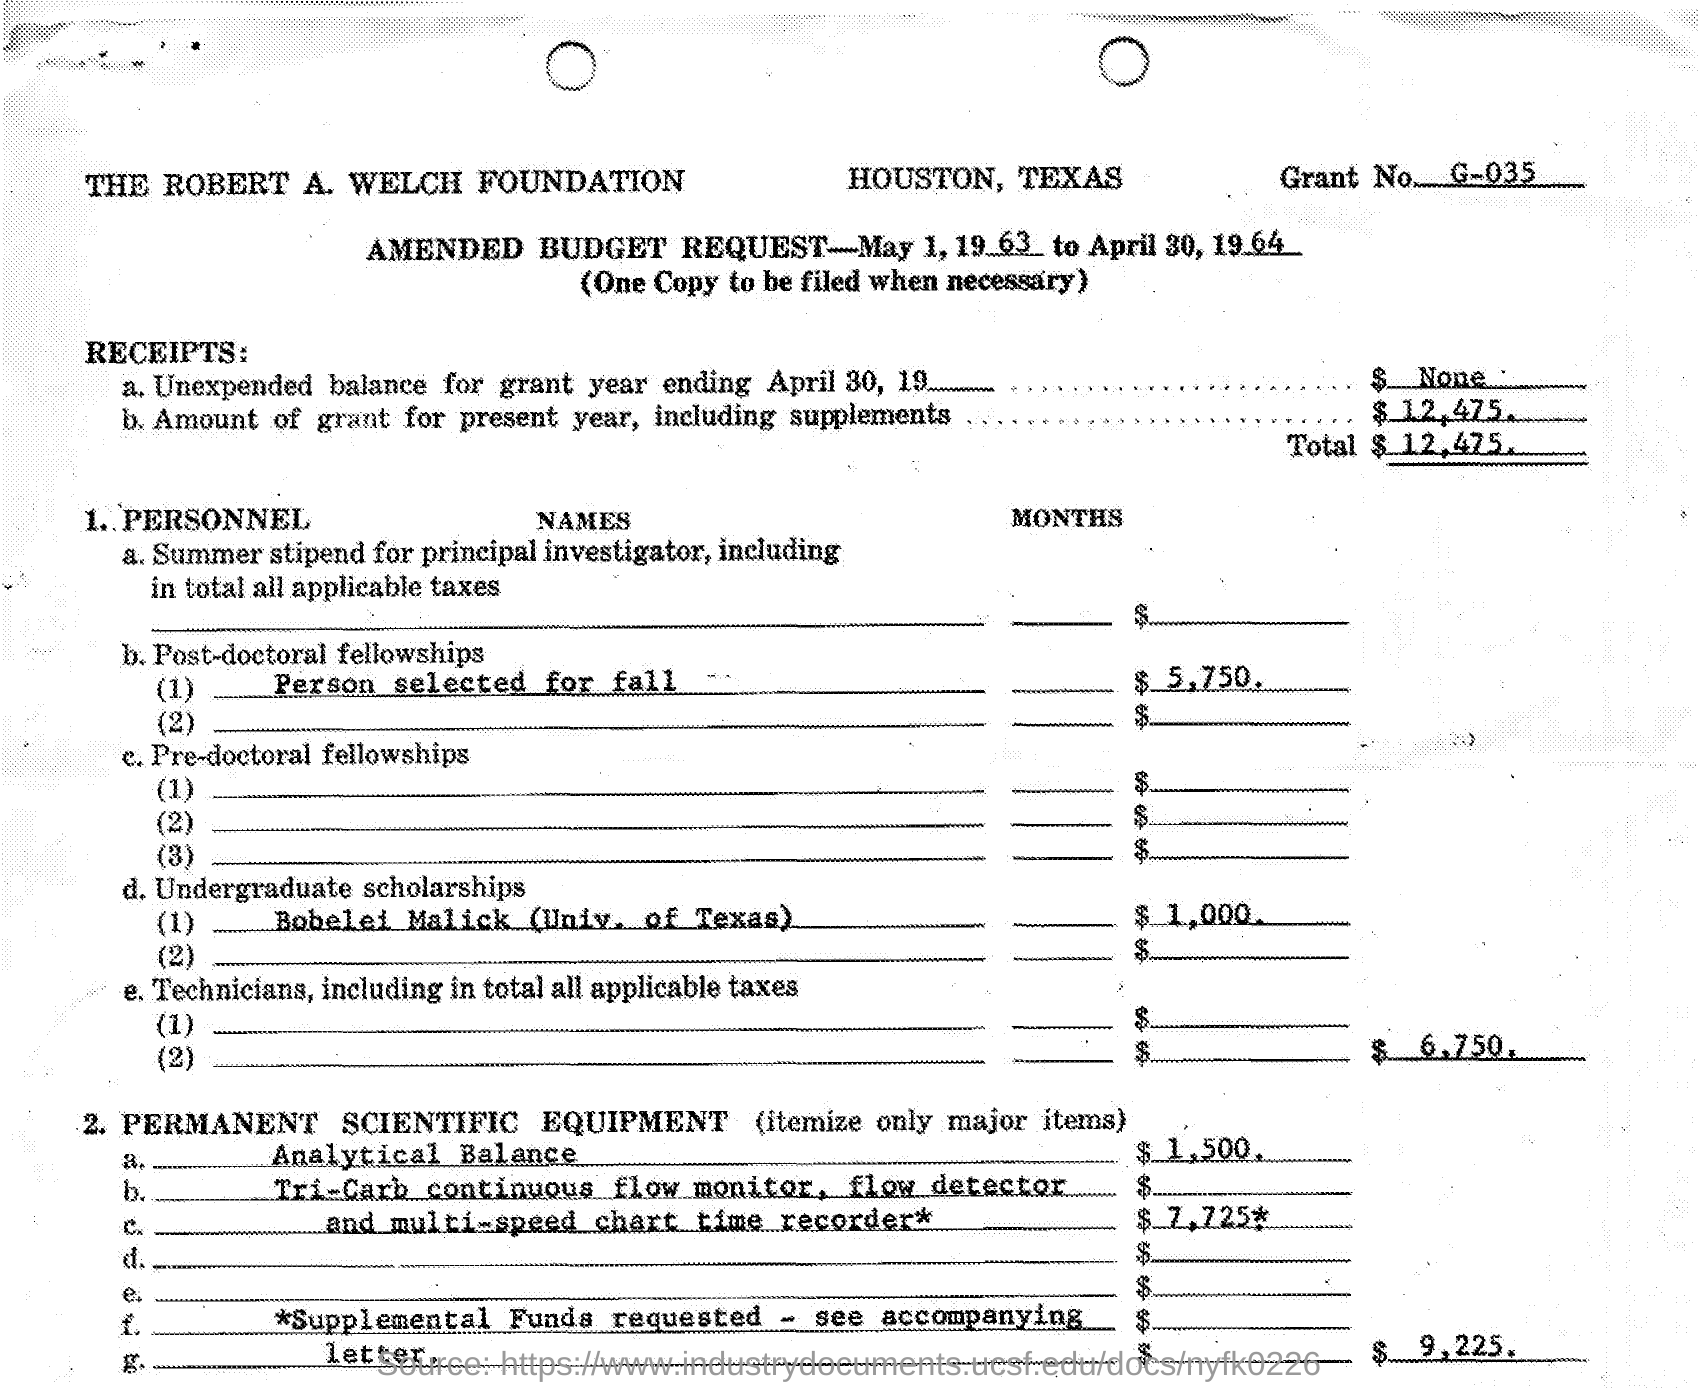Which foundation is mentioned?
Your response must be concise. THE ROBERT A. WELCH FOUNDATION. What is the grant No.?
Offer a terse response. G-035. What is the amount of Bobelei Malick (Univ. of Texas) for undergraduate scholarships?
Ensure brevity in your answer.  $ 1,000. 